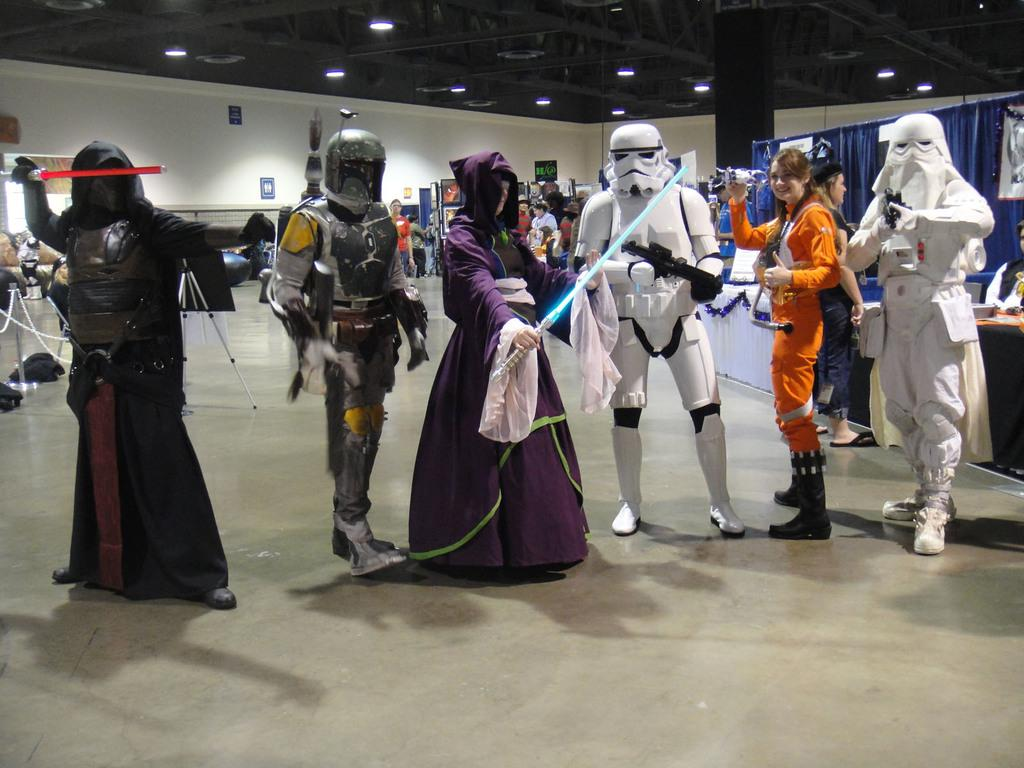What can be observed about the people in the image? There are people standing in the image, and they are wearing different costumes. Are there any other people visible in the image? Yes, there are other people standing behind them. What can be seen at the top of the image? There are lights visible on the top of the image. What type of engine can be seen powering the costumes in the image? There is no engine present in the image, and the costumes are not powered by any visible engine. 